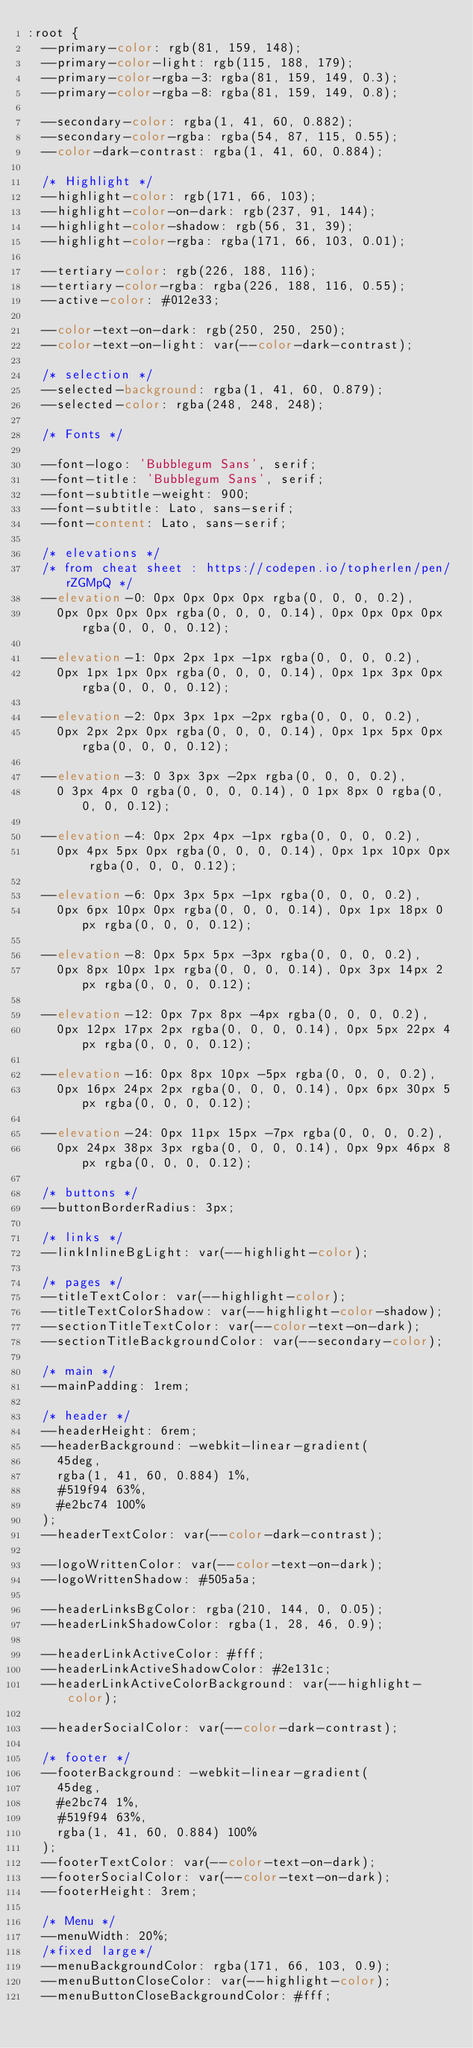Convert code to text. <code><loc_0><loc_0><loc_500><loc_500><_CSS_>:root {
  --primary-color: rgb(81, 159, 148);
  --primary-color-light: rgb(115, 188, 179);
  --primary-color-rgba-3: rgba(81, 159, 149, 0.3);
  --primary-color-rgba-8: rgba(81, 159, 149, 0.8);

  --secondary-color: rgba(1, 41, 60, 0.882);
  --secondary-color-rgba: rgba(54, 87, 115, 0.55);
  --color-dark-contrast: rgba(1, 41, 60, 0.884);

  /* Highlight */
  --highlight-color: rgb(171, 66, 103);
  --highlight-color-on-dark: rgb(237, 91, 144);
  --highlight-color-shadow: rgb(56, 31, 39);
  --highlight-color-rgba: rgba(171, 66, 103, 0.01);

  --tertiary-color: rgb(226, 188, 116);
  --tertiary-color-rgba: rgba(226, 188, 116, 0.55);
  --active-color: #012e33;

  --color-text-on-dark: rgb(250, 250, 250);
  --color-text-on-light: var(--color-dark-contrast);

  /* selection */
  --selected-background: rgba(1, 41, 60, 0.879);
  --selected-color: rgba(248, 248, 248);

  /* Fonts */

  --font-logo: 'Bubblegum Sans', serif;
  --font-title: 'Bubblegum Sans', serif;
  --font-subtitle-weight: 900;
  --font-subtitle: Lato, sans-serif;
  --font-content: Lato, sans-serif;

  /* elevations */
  /* from cheat sheet : https://codepen.io/topherlen/pen/rZGMpQ */
  --elevation-0: 0px 0px 0px 0px rgba(0, 0, 0, 0.2),
    0px 0px 0px 0px rgba(0, 0, 0, 0.14), 0px 0px 0px 0px rgba(0, 0, 0, 0.12);

  --elevation-1: 0px 2px 1px -1px rgba(0, 0, 0, 0.2),
    0px 1px 1px 0px rgba(0, 0, 0, 0.14), 0px 1px 3px 0px rgba(0, 0, 0, 0.12);

  --elevation-2: 0px 3px 1px -2px rgba(0, 0, 0, 0.2),
    0px 2px 2px 0px rgba(0, 0, 0, 0.14), 0px 1px 5px 0px rgba(0, 0, 0, 0.12);

  --elevation-3: 0 3px 3px -2px rgba(0, 0, 0, 0.2),
    0 3px 4px 0 rgba(0, 0, 0, 0.14), 0 1px 8px 0 rgba(0, 0, 0, 0.12);

  --elevation-4: 0px 2px 4px -1px rgba(0, 0, 0, 0.2),
    0px 4px 5px 0px rgba(0, 0, 0, 0.14), 0px 1px 10px 0px rgba(0, 0, 0, 0.12);

  --elevation-6: 0px 3px 5px -1px rgba(0, 0, 0, 0.2),
    0px 6px 10px 0px rgba(0, 0, 0, 0.14), 0px 1px 18px 0px rgba(0, 0, 0, 0.12);

  --elevation-8: 0px 5px 5px -3px rgba(0, 0, 0, 0.2),
    0px 8px 10px 1px rgba(0, 0, 0, 0.14), 0px 3px 14px 2px rgba(0, 0, 0, 0.12);

  --elevation-12: 0px 7px 8px -4px rgba(0, 0, 0, 0.2),
    0px 12px 17px 2px rgba(0, 0, 0, 0.14), 0px 5px 22px 4px rgba(0, 0, 0, 0.12);

  --elevation-16: 0px 8px 10px -5px rgba(0, 0, 0, 0.2),
    0px 16px 24px 2px rgba(0, 0, 0, 0.14), 0px 6px 30px 5px rgba(0, 0, 0, 0.12);

  --elevation-24: 0px 11px 15px -7px rgba(0, 0, 0, 0.2),
    0px 24px 38px 3px rgba(0, 0, 0, 0.14), 0px 9px 46px 8px rgba(0, 0, 0, 0.12);

  /* buttons */
  --buttonBorderRadius: 3px;

  /* links */
  --linkInlineBgLight: var(--highlight-color);

  /* pages */
  --titleTextColor: var(--highlight-color);
  --titleTextColorShadow: var(--highlight-color-shadow);
  --sectionTitleTextColor: var(--color-text-on-dark);
  --sectionTitleBackgroundColor: var(--secondary-color);

  /* main */
  --mainPadding: 1rem;

  /* header */
  --headerHeight: 6rem;
  --headerBackground: -webkit-linear-gradient(
    45deg,
    rgba(1, 41, 60, 0.884) 1%,
    #519f94 63%,
    #e2bc74 100%
  );
  --headerTextColor: var(--color-dark-contrast);

  --logoWrittenColor: var(--color-text-on-dark);
  --logoWrittenShadow: #505a5a;

  --headerLinksBgColor: rgba(210, 144, 0, 0.05);
  --headerLinkShadowColor: rgba(1, 28, 46, 0.9);

  --headerLinkActiveColor: #fff;
  --headerLinkActiveShadowColor: #2e131c;
  --headerLinkActiveColorBackground: var(--highlight-color);

  --headerSocialColor: var(--color-dark-contrast);

  /* footer */
  --footerBackground: -webkit-linear-gradient(
    45deg,
    #e2bc74 1%,
    #519f94 63%,
    rgba(1, 41, 60, 0.884) 100%
  );
  --footerTextColor: var(--color-text-on-dark);
  --footerSocialColor: var(--color-text-on-dark);
  --footerHeight: 3rem;

  /* Menu */
  --menuWidth: 20%;
  /*fixed large*/
  --menuBackgroundColor: rgba(171, 66, 103, 0.9);
  --menuButtonCloseColor: var(--highlight-color);
  --menuButtonCloseBackgroundColor: #fff;</code> 